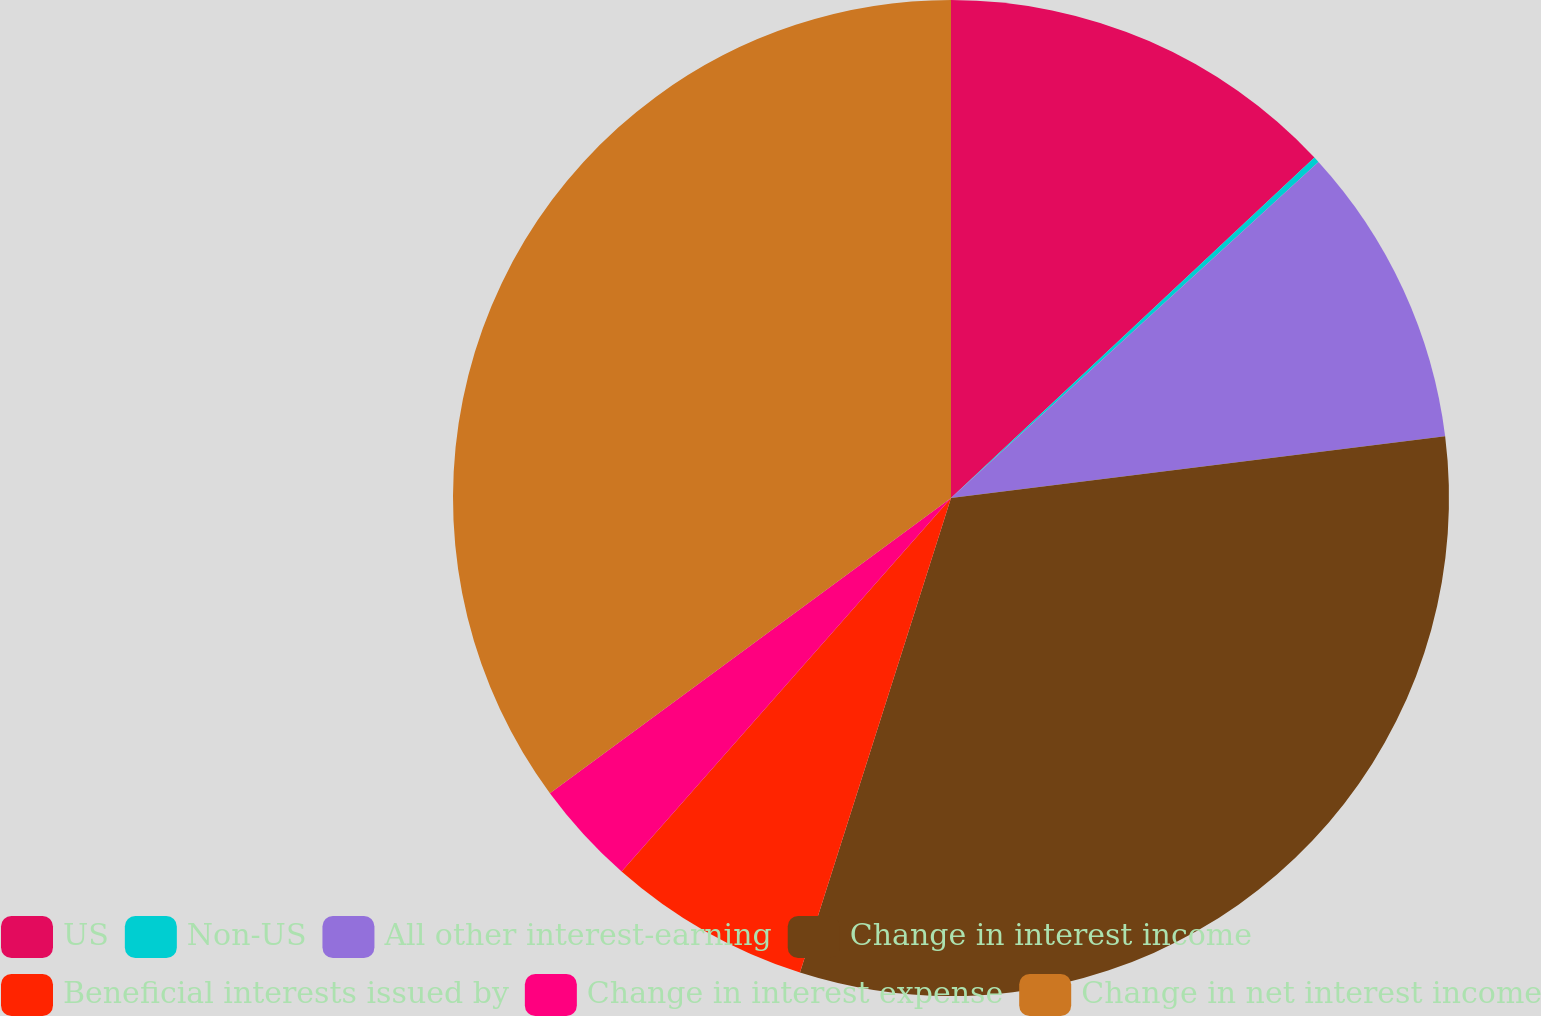Convert chart to OTSL. <chart><loc_0><loc_0><loc_500><loc_500><pie_chart><fcel>US<fcel>Non-US<fcel>All other interest-earning<fcel>Change in interest income<fcel>Beneficial interests issued by<fcel>Change in interest expense<fcel>Change in net interest income<nl><fcel>13.02%<fcel>0.19%<fcel>9.81%<fcel>31.89%<fcel>6.6%<fcel>3.4%<fcel>35.1%<nl></chart> 